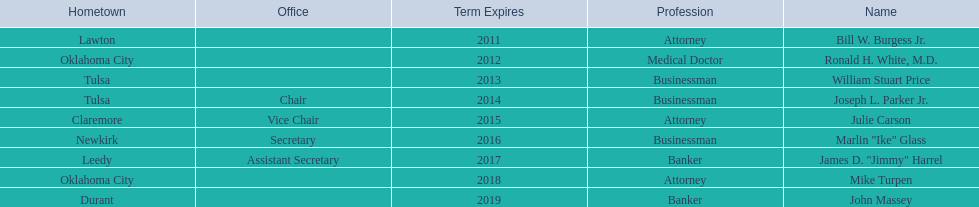Total number of members from lawton and oklahoma city 3. 